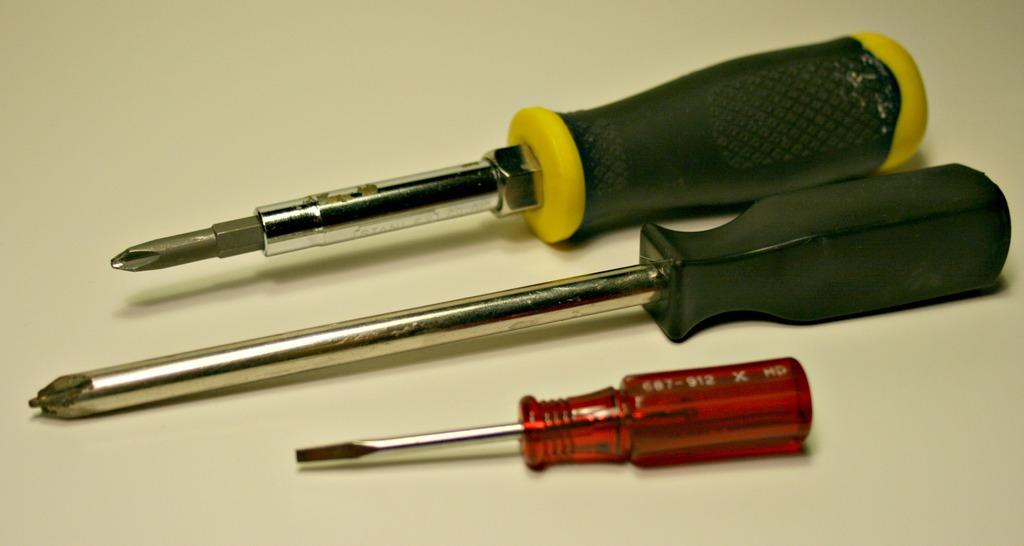How many screwdrivers are visible in the image? There are three different kinds of screwdrivers in the image. Where are the screwdrivers located in the image? The screwdrivers are on a surface in the foreground of the image. What type of pies are being served under the umbrella in the image? There is no umbrella or pies present in the image; it only features three different kinds of screwdrivers on a surface. 